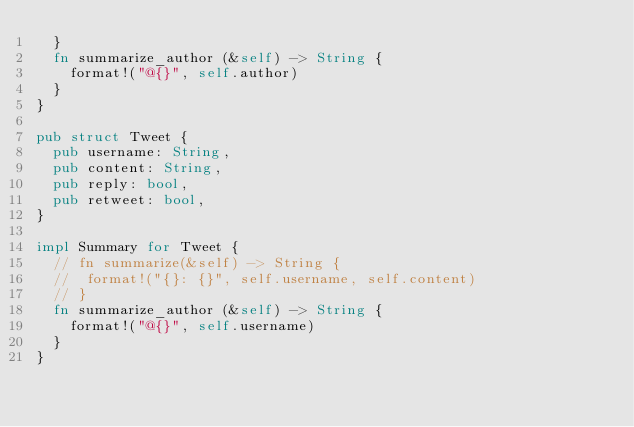<code> <loc_0><loc_0><loc_500><loc_500><_Rust_>	}
	fn summarize_author (&self) -> String {
		format!("@{}", self.author)
	}
}

pub struct Tweet {
	pub username: String,
	pub content: String,
	pub reply: bool,
	pub retweet: bool,
}

impl Summary for Tweet {
	// fn summarize(&self) -> String {
	// 	format!("{}: {}", self.username, self.content)
	// }
	fn summarize_author (&self) -> String {
		format!("@{}", self.username)
	}
}


</code> 